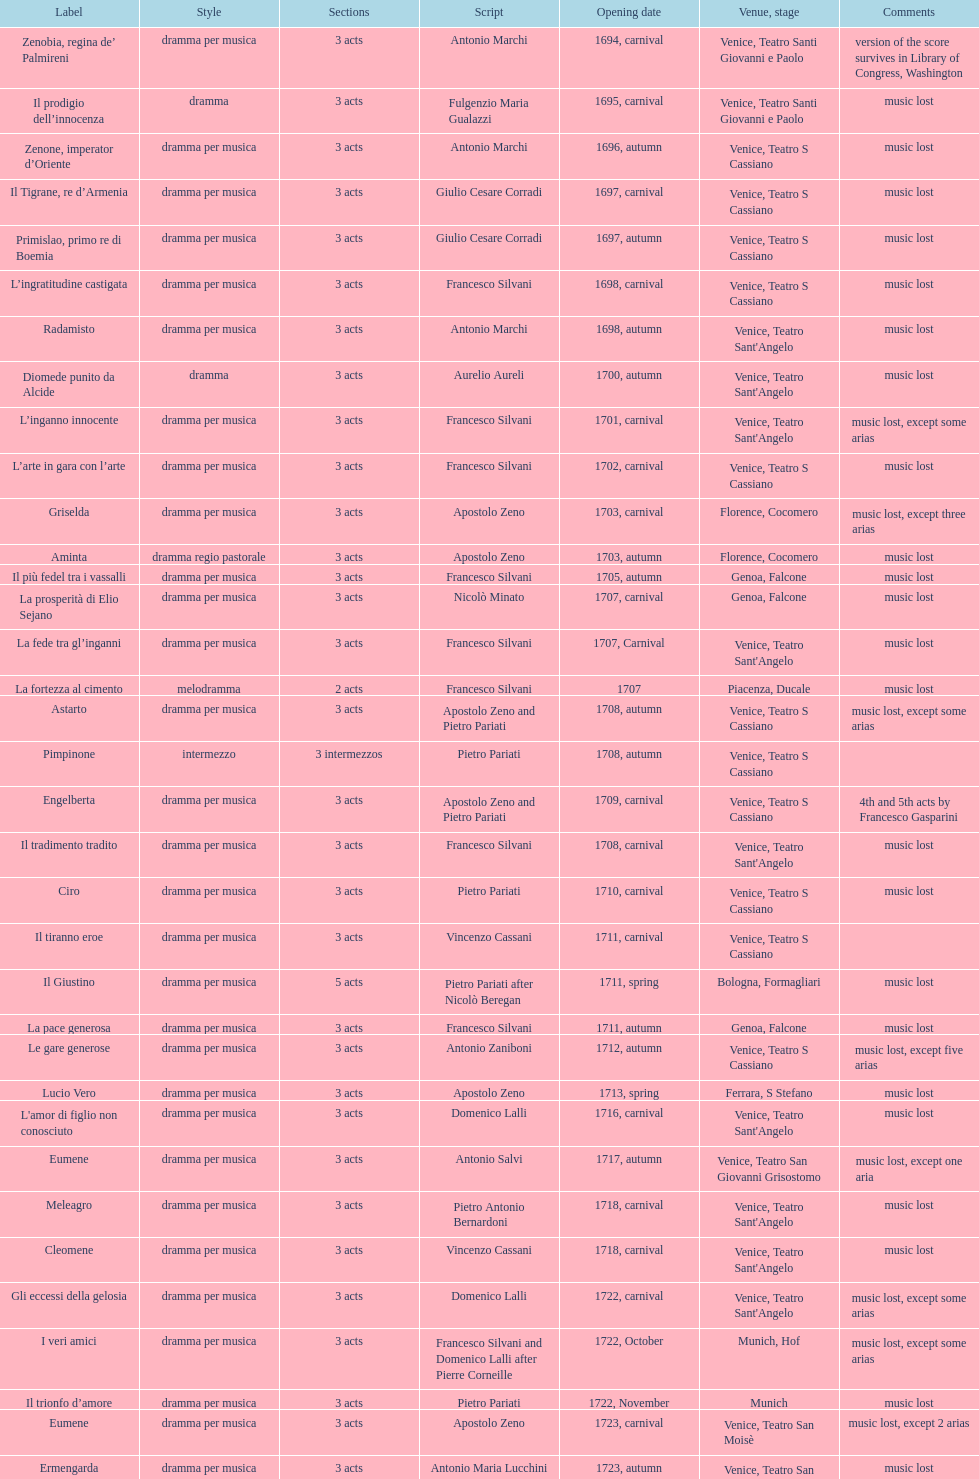L'inganno innocente premiered in 1701. what was the previous title released? Diomede punito da Alcide. 